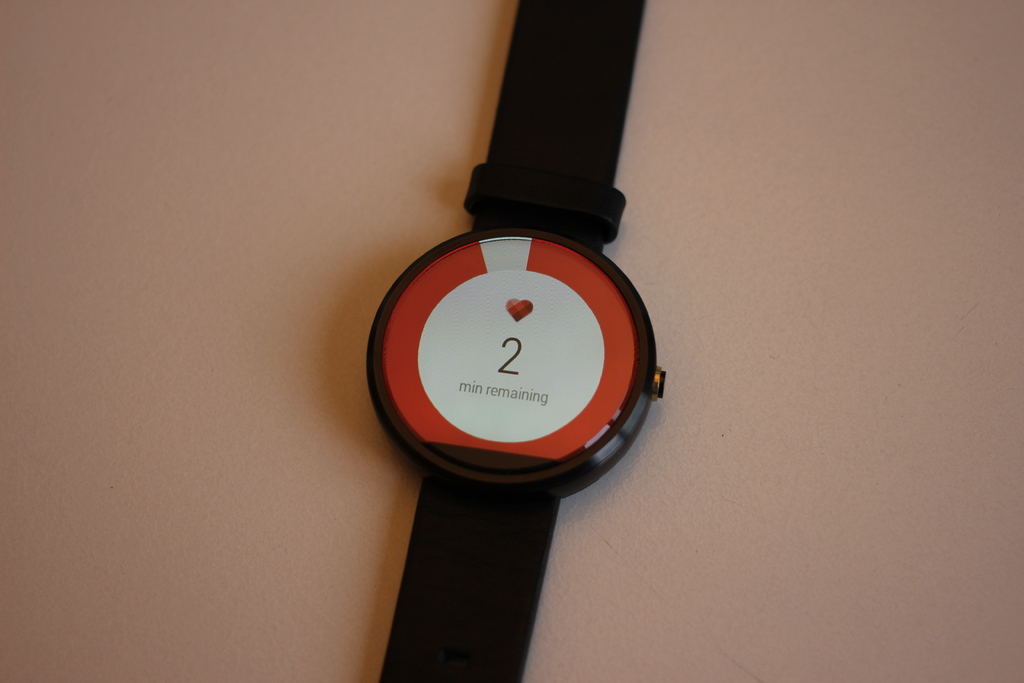Can you explain the significance of the heart symbol in the context of smartwatches? The heart symbol commonly represents health tracking features in smartwatches, such as monitoring heart rate, tracking exercise intensity, and potentially linking to health apps that monitor overall cardiovascular fitness. 